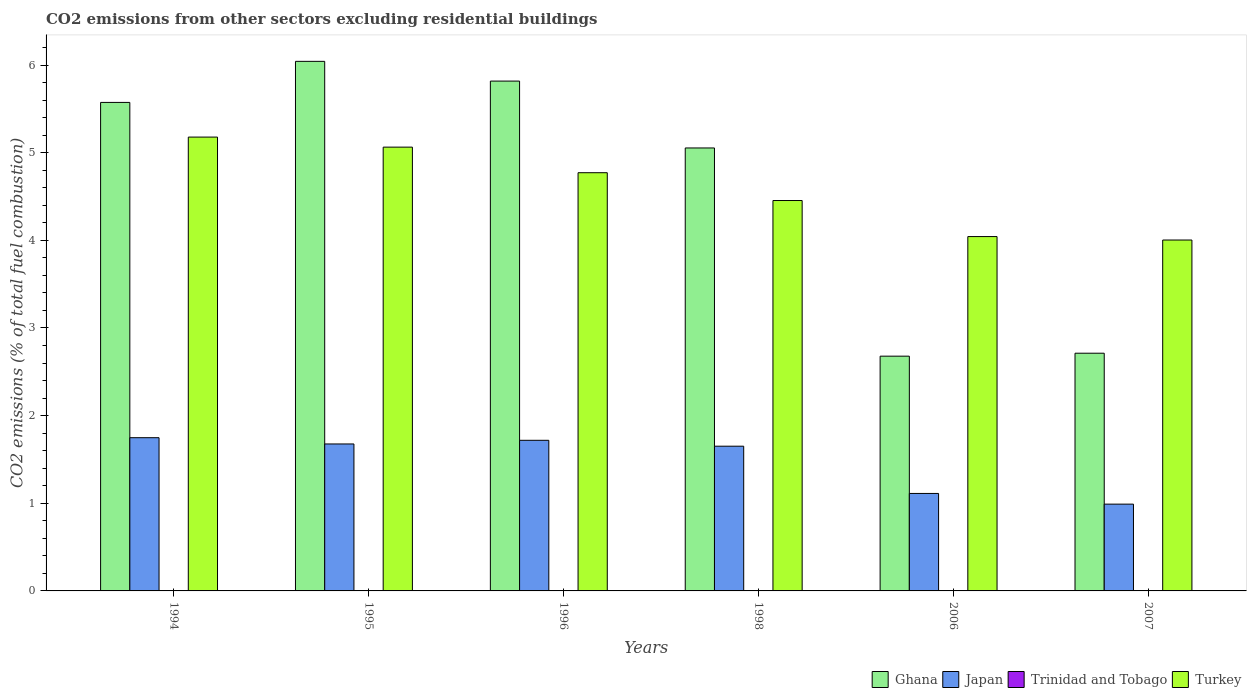How many different coloured bars are there?
Ensure brevity in your answer.  4. Are the number of bars per tick equal to the number of legend labels?
Make the answer very short. No. Are the number of bars on each tick of the X-axis equal?
Your answer should be compact. No. What is the label of the 6th group of bars from the left?
Give a very brief answer. 2007. What is the total CO2 emitted in Trinidad and Tobago in 1995?
Give a very brief answer. 0. Across all years, what is the maximum total CO2 emitted in Trinidad and Tobago?
Your answer should be very brief. 5.05750284541343e-17. Across all years, what is the minimum total CO2 emitted in Trinidad and Tobago?
Make the answer very short. 0. In which year was the total CO2 emitted in Trinidad and Tobago maximum?
Offer a very short reply. 2006. What is the total total CO2 emitted in Japan in the graph?
Offer a terse response. 8.9. What is the difference between the total CO2 emitted in Ghana in 1995 and that in 2006?
Make the answer very short. 3.36. What is the difference between the total CO2 emitted in Japan in 1998 and the total CO2 emitted in Turkey in 2006?
Make the answer very short. -2.39. What is the average total CO2 emitted in Trinidad and Tobago per year?
Ensure brevity in your answer.  1.6352453933809117e-17. In the year 1998, what is the difference between the total CO2 emitted in Turkey and total CO2 emitted in Ghana?
Offer a very short reply. -0.6. What is the ratio of the total CO2 emitted in Turkey in 1994 to that in 1998?
Provide a succinct answer. 1.16. Is the total CO2 emitted in Turkey in 1996 less than that in 2007?
Your answer should be compact. No. Is the difference between the total CO2 emitted in Turkey in 1995 and 1996 greater than the difference between the total CO2 emitted in Ghana in 1995 and 1996?
Provide a short and direct response. Yes. What is the difference between the highest and the second highest total CO2 emitted in Ghana?
Your answer should be very brief. 0.23. What is the difference between the highest and the lowest total CO2 emitted in Japan?
Offer a terse response. 0.76. In how many years, is the total CO2 emitted in Turkey greater than the average total CO2 emitted in Turkey taken over all years?
Give a very brief answer. 3. Is the sum of the total CO2 emitted in Japan in 1996 and 2007 greater than the maximum total CO2 emitted in Ghana across all years?
Give a very brief answer. No. Is it the case that in every year, the sum of the total CO2 emitted in Trinidad and Tobago and total CO2 emitted in Turkey is greater than the sum of total CO2 emitted in Ghana and total CO2 emitted in Japan?
Your answer should be very brief. No. How many bars are there?
Give a very brief answer. 20. How many years are there in the graph?
Provide a short and direct response. 6. What is the difference between two consecutive major ticks on the Y-axis?
Keep it short and to the point. 1. Are the values on the major ticks of Y-axis written in scientific E-notation?
Keep it short and to the point. No. Does the graph contain any zero values?
Your response must be concise. Yes. Does the graph contain grids?
Your answer should be compact. No. Where does the legend appear in the graph?
Offer a terse response. Bottom right. What is the title of the graph?
Ensure brevity in your answer.  CO2 emissions from other sectors excluding residential buildings. What is the label or title of the X-axis?
Provide a succinct answer. Years. What is the label or title of the Y-axis?
Your answer should be compact. CO2 emissions (% of total fuel combustion). What is the CO2 emissions (% of total fuel combustion) in Ghana in 1994?
Your answer should be very brief. 5.57. What is the CO2 emissions (% of total fuel combustion) of Japan in 1994?
Make the answer very short. 1.75. What is the CO2 emissions (% of total fuel combustion) in Turkey in 1994?
Give a very brief answer. 5.18. What is the CO2 emissions (% of total fuel combustion) of Ghana in 1995?
Your response must be concise. 6.04. What is the CO2 emissions (% of total fuel combustion) of Japan in 1995?
Your answer should be very brief. 1.68. What is the CO2 emissions (% of total fuel combustion) of Turkey in 1995?
Offer a terse response. 5.06. What is the CO2 emissions (% of total fuel combustion) of Ghana in 1996?
Make the answer very short. 5.82. What is the CO2 emissions (% of total fuel combustion) of Japan in 1996?
Offer a very short reply. 1.72. What is the CO2 emissions (% of total fuel combustion) in Turkey in 1996?
Give a very brief answer. 4.77. What is the CO2 emissions (% of total fuel combustion) in Ghana in 1998?
Offer a terse response. 5.05. What is the CO2 emissions (% of total fuel combustion) in Japan in 1998?
Offer a very short reply. 1.65. What is the CO2 emissions (% of total fuel combustion) in Turkey in 1998?
Offer a very short reply. 4.45. What is the CO2 emissions (% of total fuel combustion) in Ghana in 2006?
Your response must be concise. 2.68. What is the CO2 emissions (% of total fuel combustion) in Japan in 2006?
Provide a succinct answer. 1.11. What is the CO2 emissions (% of total fuel combustion) in Trinidad and Tobago in 2006?
Your answer should be compact. 5.05750284541343e-17. What is the CO2 emissions (% of total fuel combustion) in Turkey in 2006?
Your answer should be compact. 4.04. What is the CO2 emissions (% of total fuel combustion) of Ghana in 2007?
Offer a very short reply. 2.71. What is the CO2 emissions (% of total fuel combustion) in Japan in 2007?
Offer a terse response. 0.99. What is the CO2 emissions (% of total fuel combustion) of Trinidad and Tobago in 2007?
Provide a short and direct response. 4.75396951487204e-17. What is the CO2 emissions (% of total fuel combustion) in Turkey in 2007?
Keep it short and to the point. 4. Across all years, what is the maximum CO2 emissions (% of total fuel combustion) of Ghana?
Give a very brief answer. 6.04. Across all years, what is the maximum CO2 emissions (% of total fuel combustion) in Japan?
Keep it short and to the point. 1.75. Across all years, what is the maximum CO2 emissions (% of total fuel combustion) in Trinidad and Tobago?
Your answer should be compact. 5.05750284541343e-17. Across all years, what is the maximum CO2 emissions (% of total fuel combustion) of Turkey?
Provide a succinct answer. 5.18. Across all years, what is the minimum CO2 emissions (% of total fuel combustion) of Ghana?
Provide a short and direct response. 2.68. Across all years, what is the minimum CO2 emissions (% of total fuel combustion) in Japan?
Provide a succinct answer. 0.99. Across all years, what is the minimum CO2 emissions (% of total fuel combustion) in Turkey?
Offer a terse response. 4. What is the total CO2 emissions (% of total fuel combustion) in Ghana in the graph?
Your response must be concise. 27.88. What is the total CO2 emissions (% of total fuel combustion) in Japan in the graph?
Provide a succinct answer. 8.9. What is the total CO2 emissions (% of total fuel combustion) in Turkey in the graph?
Provide a succinct answer. 27.51. What is the difference between the CO2 emissions (% of total fuel combustion) in Ghana in 1994 and that in 1995?
Your answer should be compact. -0.47. What is the difference between the CO2 emissions (% of total fuel combustion) of Japan in 1994 and that in 1995?
Your response must be concise. 0.07. What is the difference between the CO2 emissions (% of total fuel combustion) of Turkey in 1994 and that in 1995?
Provide a short and direct response. 0.11. What is the difference between the CO2 emissions (% of total fuel combustion) in Ghana in 1994 and that in 1996?
Your answer should be compact. -0.24. What is the difference between the CO2 emissions (% of total fuel combustion) of Japan in 1994 and that in 1996?
Make the answer very short. 0.03. What is the difference between the CO2 emissions (% of total fuel combustion) of Turkey in 1994 and that in 1996?
Provide a succinct answer. 0.41. What is the difference between the CO2 emissions (% of total fuel combustion) of Ghana in 1994 and that in 1998?
Keep it short and to the point. 0.52. What is the difference between the CO2 emissions (% of total fuel combustion) in Japan in 1994 and that in 1998?
Provide a short and direct response. 0.1. What is the difference between the CO2 emissions (% of total fuel combustion) in Turkey in 1994 and that in 1998?
Offer a terse response. 0.72. What is the difference between the CO2 emissions (% of total fuel combustion) of Ghana in 1994 and that in 2006?
Your response must be concise. 2.9. What is the difference between the CO2 emissions (% of total fuel combustion) in Japan in 1994 and that in 2006?
Provide a succinct answer. 0.64. What is the difference between the CO2 emissions (% of total fuel combustion) of Turkey in 1994 and that in 2006?
Offer a very short reply. 1.14. What is the difference between the CO2 emissions (% of total fuel combustion) of Ghana in 1994 and that in 2007?
Provide a short and direct response. 2.86. What is the difference between the CO2 emissions (% of total fuel combustion) in Japan in 1994 and that in 2007?
Make the answer very short. 0.76. What is the difference between the CO2 emissions (% of total fuel combustion) in Turkey in 1994 and that in 2007?
Ensure brevity in your answer.  1.17. What is the difference between the CO2 emissions (% of total fuel combustion) in Ghana in 1995 and that in 1996?
Ensure brevity in your answer.  0.23. What is the difference between the CO2 emissions (% of total fuel combustion) in Japan in 1995 and that in 1996?
Offer a terse response. -0.04. What is the difference between the CO2 emissions (% of total fuel combustion) in Turkey in 1995 and that in 1996?
Give a very brief answer. 0.29. What is the difference between the CO2 emissions (% of total fuel combustion) in Ghana in 1995 and that in 1998?
Your answer should be very brief. 0.99. What is the difference between the CO2 emissions (% of total fuel combustion) in Japan in 1995 and that in 1998?
Provide a short and direct response. 0.03. What is the difference between the CO2 emissions (% of total fuel combustion) in Turkey in 1995 and that in 1998?
Offer a very short reply. 0.61. What is the difference between the CO2 emissions (% of total fuel combustion) in Ghana in 1995 and that in 2006?
Keep it short and to the point. 3.36. What is the difference between the CO2 emissions (% of total fuel combustion) in Japan in 1995 and that in 2006?
Your answer should be very brief. 0.56. What is the difference between the CO2 emissions (% of total fuel combustion) of Turkey in 1995 and that in 2006?
Offer a very short reply. 1.02. What is the difference between the CO2 emissions (% of total fuel combustion) of Ghana in 1995 and that in 2007?
Your answer should be very brief. 3.33. What is the difference between the CO2 emissions (% of total fuel combustion) in Japan in 1995 and that in 2007?
Your answer should be very brief. 0.69. What is the difference between the CO2 emissions (% of total fuel combustion) in Turkey in 1995 and that in 2007?
Offer a very short reply. 1.06. What is the difference between the CO2 emissions (% of total fuel combustion) of Ghana in 1996 and that in 1998?
Make the answer very short. 0.76. What is the difference between the CO2 emissions (% of total fuel combustion) of Japan in 1996 and that in 1998?
Ensure brevity in your answer.  0.07. What is the difference between the CO2 emissions (% of total fuel combustion) in Turkey in 1996 and that in 1998?
Offer a terse response. 0.32. What is the difference between the CO2 emissions (% of total fuel combustion) of Ghana in 1996 and that in 2006?
Offer a very short reply. 3.14. What is the difference between the CO2 emissions (% of total fuel combustion) in Japan in 1996 and that in 2006?
Make the answer very short. 0.61. What is the difference between the CO2 emissions (% of total fuel combustion) in Turkey in 1996 and that in 2006?
Your response must be concise. 0.73. What is the difference between the CO2 emissions (% of total fuel combustion) in Ghana in 1996 and that in 2007?
Give a very brief answer. 3.1. What is the difference between the CO2 emissions (% of total fuel combustion) of Japan in 1996 and that in 2007?
Give a very brief answer. 0.73. What is the difference between the CO2 emissions (% of total fuel combustion) of Turkey in 1996 and that in 2007?
Provide a succinct answer. 0.77. What is the difference between the CO2 emissions (% of total fuel combustion) in Ghana in 1998 and that in 2006?
Offer a terse response. 2.38. What is the difference between the CO2 emissions (% of total fuel combustion) in Japan in 1998 and that in 2006?
Offer a very short reply. 0.54. What is the difference between the CO2 emissions (% of total fuel combustion) in Turkey in 1998 and that in 2006?
Keep it short and to the point. 0.41. What is the difference between the CO2 emissions (% of total fuel combustion) of Ghana in 1998 and that in 2007?
Give a very brief answer. 2.34. What is the difference between the CO2 emissions (% of total fuel combustion) of Japan in 1998 and that in 2007?
Provide a short and direct response. 0.66. What is the difference between the CO2 emissions (% of total fuel combustion) in Turkey in 1998 and that in 2007?
Keep it short and to the point. 0.45. What is the difference between the CO2 emissions (% of total fuel combustion) of Ghana in 2006 and that in 2007?
Offer a terse response. -0.03. What is the difference between the CO2 emissions (% of total fuel combustion) of Japan in 2006 and that in 2007?
Your answer should be compact. 0.12. What is the difference between the CO2 emissions (% of total fuel combustion) in Trinidad and Tobago in 2006 and that in 2007?
Your response must be concise. 0. What is the difference between the CO2 emissions (% of total fuel combustion) of Turkey in 2006 and that in 2007?
Keep it short and to the point. 0.04. What is the difference between the CO2 emissions (% of total fuel combustion) of Ghana in 1994 and the CO2 emissions (% of total fuel combustion) of Japan in 1995?
Make the answer very short. 3.9. What is the difference between the CO2 emissions (% of total fuel combustion) of Ghana in 1994 and the CO2 emissions (% of total fuel combustion) of Turkey in 1995?
Provide a short and direct response. 0.51. What is the difference between the CO2 emissions (% of total fuel combustion) in Japan in 1994 and the CO2 emissions (% of total fuel combustion) in Turkey in 1995?
Provide a short and direct response. -3.32. What is the difference between the CO2 emissions (% of total fuel combustion) of Ghana in 1994 and the CO2 emissions (% of total fuel combustion) of Japan in 1996?
Your answer should be compact. 3.86. What is the difference between the CO2 emissions (% of total fuel combustion) of Ghana in 1994 and the CO2 emissions (% of total fuel combustion) of Turkey in 1996?
Give a very brief answer. 0.8. What is the difference between the CO2 emissions (% of total fuel combustion) of Japan in 1994 and the CO2 emissions (% of total fuel combustion) of Turkey in 1996?
Give a very brief answer. -3.02. What is the difference between the CO2 emissions (% of total fuel combustion) of Ghana in 1994 and the CO2 emissions (% of total fuel combustion) of Japan in 1998?
Provide a succinct answer. 3.92. What is the difference between the CO2 emissions (% of total fuel combustion) in Ghana in 1994 and the CO2 emissions (% of total fuel combustion) in Turkey in 1998?
Ensure brevity in your answer.  1.12. What is the difference between the CO2 emissions (% of total fuel combustion) of Japan in 1994 and the CO2 emissions (% of total fuel combustion) of Turkey in 1998?
Provide a short and direct response. -2.71. What is the difference between the CO2 emissions (% of total fuel combustion) in Ghana in 1994 and the CO2 emissions (% of total fuel combustion) in Japan in 2006?
Provide a short and direct response. 4.46. What is the difference between the CO2 emissions (% of total fuel combustion) of Ghana in 1994 and the CO2 emissions (% of total fuel combustion) of Trinidad and Tobago in 2006?
Your answer should be compact. 5.57. What is the difference between the CO2 emissions (% of total fuel combustion) in Ghana in 1994 and the CO2 emissions (% of total fuel combustion) in Turkey in 2006?
Give a very brief answer. 1.53. What is the difference between the CO2 emissions (% of total fuel combustion) of Japan in 1994 and the CO2 emissions (% of total fuel combustion) of Trinidad and Tobago in 2006?
Offer a terse response. 1.75. What is the difference between the CO2 emissions (% of total fuel combustion) in Japan in 1994 and the CO2 emissions (% of total fuel combustion) in Turkey in 2006?
Offer a very short reply. -2.29. What is the difference between the CO2 emissions (% of total fuel combustion) of Ghana in 1994 and the CO2 emissions (% of total fuel combustion) of Japan in 2007?
Offer a terse response. 4.58. What is the difference between the CO2 emissions (% of total fuel combustion) in Ghana in 1994 and the CO2 emissions (% of total fuel combustion) in Trinidad and Tobago in 2007?
Provide a short and direct response. 5.57. What is the difference between the CO2 emissions (% of total fuel combustion) of Ghana in 1994 and the CO2 emissions (% of total fuel combustion) of Turkey in 2007?
Give a very brief answer. 1.57. What is the difference between the CO2 emissions (% of total fuel combustion) in Japan in 1994 and the CO2 emissions (% of total fuel combustion) in Trinidad and Tobago in 2007?
Offer a very short reply. 1.75. What is the difference between the CO2 emissions (% of total fuel combustion) in Japan in 1994 and the CO2 emissions (% of total fuel combustion) in Turkey in 2007?
Provide a short and direct response. -2.26. What is the difference between the CO2 emissions (% of total fuel combustion) in Ghana in 1995 and the CO2 emissions (% of total fuel combustion) in Japan in 1996?
Give a very brief answer. 4.32. What is the difference between the CO2 emissions (% of total fuel combustion) of Ghana in 1995 and the CO2 emissions (% of total fuel combustion) of Turkey in 1996?
Your answer should be very brief. 1.27. What is the difference between the CO2 emissions (% of total fuel combustion) of Japan in 1995 and the CO2 emissions (% of total fuel combustion) of Turkey in 1996?
Your answer should be very brief. -3.09. What is the difference between the CO2 emissions (% of total fuel combustion) of Ghana in 1995 and the CO2 emissions (% of total fuel combustion) of Japan in 1998?
Provide a succinct answer. 4.39. What is the difference between the CO2 emissions (% of total fuel combustion) in Ghana in 1995 and the CO2 emissions (% of total fuel combustion) in Turkey in 1998?
Ensure brevity in your answer.  1.59. What is the difference between the CO2 emissions (% of total fuel combustion) of Japan in 1995 and the CO2 emissions (% of total fuel combustion) of Turkey in 1998?
Provide a short and direct response. -2.78. What is the difference between the CO2 emissions (% of total fuel combustion) in Ghana in 1995 and the CO2 emissions (% of total fuel combustion) in Japan in 2006?
Give a very brief answer. 4.93. What is the difference between the CO2 emissions (% of total fuel combustion) of Ghana in 1995 and the CO2 emissions (% of total fuel combustion) of Trinidad and Tobago in 2006?
Provide a short and direct response. 6.04. What is the difference between the CO2 emissions (% of total fuel combustion) of Ghana in 1995 and the CO2 emissions (% of total fuel combustion) of Turkey in 2006?
Provide a succinct answer. 2. What is the difference between the CO2 emissions (% of total fuel combustion) in Japan in 1995 and the CO2 emissions (% of total fuel combustion) in Trinidad and Tobago in 2006?
Your answer should be compact. 1.68. What is the difference between the CO2 emissions (% of total fuel combustion) of Japan in 1995 and the CO2 emissions (% of total fuel combustion) of Turkey in 2006?
Offer a terse response. -2.37. What is the difference between the CO2 emissions (% of total fuel combustion) in Ghana in 1995 and the CO2 emissions (% of total fuel combustion) in Japan in 2007?
Give a very brief answer. 5.05. What is the difference between the CO2 emissions (% of total fuel combustion) in Ghana in 1995 and the CO2 emissions (% of total fuel combustion) in Trinidad and Tobago in 2007?
Make the answer very short. 6.04. What is the difference between the CO2 emissions (% of total fuel combustion) in Ghana in 1995 and the CO2 emissions (% of total fuel combustion) in Turkey in 2007?
Offer a very short reply. 2.04. What is the difference between the CO2 emissions (% of total fuel combustion) of Japan in 1995 and the CO2 emissions (% of total fuel combustion) of Trinidad and Tobago in 2007?
Provide a short and direct response. 1.68. What is the difference between the CO2 emissions (% of total fuel combustion) in Japan in 1995 and the CO2 emissions (% of total fuel combustion) in Turkey in 2007?
Your answer should be very brief. -2.33. What is the difference between the CO2 emissions (% of total fuel combustion) of Ghana in 1996 and the CO2 emissions (% of total fuel combustion) of Japan in 1998?
Offer a very short reply. 4.17. What is the difference between the CO2 emissions (% of total fuel combustion) of Ghana in 1996 and the CO2 emissions (% of total fuel combustion) of Turkey in 1998?
Offer a very short reply. 1.36. What is the difference between the CO2 emissions (% of total fuel combustion) of Japan in 1996 and the CO2 emissions (% of total fuel combustion) of Turkey in 1998?
Keep it short and to the point. -2.74. What is the difference between the CO2 emissions (% of total fuel combustion) of Ghana in 1996 and the CO2 emissions (% of total fuel combustion) of Japan in 2006?
Your response must be concise. 4.7. What is the difference between the CO2 emissions (% of total fuel combustion) of Ghana in 1996 and the CO2 emissions (% of total fuel combustion) of Trinidad and Tobago in 2006?
Give a very brief answer. 5.82. What is the difference between the CO2 emissions (% of total fuel combustion) of Ghana in 1996 and the CO2 emissions (% of total fuel combustion) of Turkey in 2006?
Your response must be concise. 1.77. What is the difference between the CO2 emissions (% of total fuel combustion) in Japan in 1996 and the CO2 emissions (% of total fuel combustion) in Trinidad and Tobago in 2006?
Keep it short and to the point. 1.72. What is the difference between the CO2 emissions (% of total fuel combustion) of Japan in 1996 and the CO2 emissions (% of total fuel combustion) of Turkey in 2006?
Give a very brief answer. -2.32. What is the difference between the CO2 emissions (% of total fuel combustion) in Ghana in 1996 and the CO2 emissions (% of total fuel combustion) in Japan in 2007?
Your response must be concise. 4.83. What is the difference between the CO2 emissions (% of total fuel combustion) in Ghana in 1996 and the CO2 emissions (% of total fuel combustion) in Trinidad and Tobago in 2007?
Provide a short and direct response. 5.82. What is the difference between the CO2 emissions (% of total fuel combustion) in Ghana in 1996 and the CO2 emissions (% of total fuel combustion) in Turkey in 2007?
Your response must be concise. 1.81. What is the difference between the CO2 emissions (% of total fuel combustion) in Japan in 1996 and the CO2 emissions (% of total fuel combustion) in Trinidad and Tobago in 2007?
Keep it short and to the point. 1.72. What is the difference between the CO2 emissions (% of total fuel combustion) of Japan in 1996 and the CO2 emissions (% of total fuel combustion) of Turkey in 2007?
Keep it short and to the point. -2.29. What is the difference between the CO2 emissions (% of total fuel combustion) of Ghana in 1998 and the CO2 emissions (% of total fuel combustion) of Japan in 2006?
Make the answer very short. 3.94. What is the difference between the CO2 emissions (% of total fuel combustion) of Ghana in 1998 and the CO2 emissions (% of total fuel combustion) of Trinidad and Tobago in 2006?
Your response must be concise. 5.05. What is the difference between the CO2 emissions (% of total fuel combustion) in Ghana in 1998 and the CO2 emissions (% of total fuel combustion) in Turkey in 2006?
Offer a terse response. 1.01. What is the difference between the CO2 emissions (% of total fuel combustion) of Japan in 1998 and the CO2 emissions (% of total fuel combustion) of Trinidad and Tobago in 2006?
Provide a succinct answer. 1.65. What is the difference between the CO2 emissions (% of total fuel combustion) of Japan in 1998 and the CO2 emissions (% of total fuel combustion) of Turkey in 2006?
Make the answer very short. -2.39. What is the difference between the CO2 emissions (% of total fuel combustion) in Ghana in 1998 and the CO2 emissions (% of total fuel combustion) in Japan in 2007?
Provide a short and direct response. 4.06. What is the difference between the CO2 emissions (% of total fuel combustion) in Ghana in 1998 and the CO2 emissions (% of total fuel combustion) in Trinidad and Tobago in 2007?
Give a very brief answer. 5.05. What is the difference between the CO2 emissions (% of total fuel combustion) in Ghana in 1998 and the CO2 emissions (% of total fuel combustion) in Turkey in 2007?
Your answer should be compact. 1.05. What is the difference between the CO2 emissions (% of total fuel combustion) of Japan in 1998 and the CO2 emissions (% of total fuel combustion) of Trinidad and Tobago in 2007?
Make the answer very short. 1.65. What is the difference between the CO2 emissions (% of total fuel combustion) of Japan in 1998 and the CO2 emissions (% of total fuel combustion) of Turkey in 2007?
Your answer should be very brief. -2.35. What is the difference between the CO2 emissions (% of total fuel combustion) in Ghana in 2006 and the CO2 emissions (% of total fuel combustion) in Japan in 2007?
Your answer should be compact. 1.69. What is the difference between the CO2 emissions (% of total fuel combustion) of Ghana in 2006 and the CO2 emissions (% of total fuel combustion) of Trinidad and Tobago in 2007?
Make the answer very short. 2.68. What is the difference between the CO2 emissions (% of total fuel combustion) of Ghana in 2006 and the CO2 emissions (% of total fuel combustion) of Turkey in 2007?
Your answer should be very brief. -1.33. What is the difference between the CO2 emissions (% of total fuel combustion) of Japan in 2006 and the CO2 emissions (% of total fuel combustion) of Trinidad and Tobago in 2007?
Your response must be concise. 1.11. What is the difference between the CO2 emissions (% of total fuel combustion) of Japan in 2006 and the CO2 emissions (% of total fuel combustion) of Turkey in 2007?
Your answer should be very brief. -2.89. What is the difference between the CO2 emissions (% of total fuel combustion) in Trinidad and Tobago in 2006 and the CO2 emissions (% of total fuel combustion) in Turkey in 2007?
Provide a short and direct response. -4. What is the average CO2 emissions (% of total fuel combustion) of Ghana per year?
Offer a very short reply. 4.65. What is the average CO2 emissions (% of total fuel combustion) in Japan per year?
Make the answer very short. 1.48. What is the average CO2 emissions (% of total fuel combustion) in Trinidad and Tobago per year?
Your answer should be very brief. 0. What is the average CO2 emissions (% of total fuel combustion) in Turkey per year?
Offer a very short reply. 4.59. In the year 1994, what is the difference between the CO2 emissions (% of total fuel combustion) of Ghana and CO2 emissions (% of total fuel combustion) of Japan?
Offer a very short reply. 3.83. In the year 1994, what is the difference between the CO2 emissions (% of total fuel combustion) in Ghana and CO2 emissions (% of total fuel combustion) in Turkey?
Provide a succinct answer. 0.4. In the year 1994, what is the difference between the CO2 emissions (% of total fuel combustion) in Japan and CO2 emissions (% of total fuel combustion) in Turkey?
Give a very brief answer. -3.43. In the year 1995, what is the difference between the CO2 emissions (% of total fuel combustion) in Ghana and CO2 emissions (% of total fuel combustion) in Japan?
Offer a very short reply. 4.37. In the year 1995, what is the difference between the CO2 emissions (% of total fuel combustion) in Ghana and CO2 emissions (% of total fuel combustion) in Turkey?
Make the answer very short. 0.98. In the year 1995, what is the difference between the CO2 emissions (% of total fuel combustion) in Japan and CO2 emissions (% of total fuel combustion) in Turkey?
Ensure brevity in your answer.  -3.39. In the year 1996, what is the difference between the CO2 emissions (% of total fuel combustion) in Ghana and CO2 emissions (% of total fuel combustion) in Japan?
Offer a very short reply. 4.1. In the year 1996, what is the difference between the CO2 emissions (% of total fuel combustion) of Ghana and CO2 emissions (% of total fuel combustion) of Turkey?
Offer a very short reply. 1.05. In the year 1996, what is the difference between the CO2 emissions (% of total fuel combustion) of Japan and CO2 emissions (% of total fuel combustion) of Turkey?
Provide a short and direct response. -3.05. In the year 1998, what is the difference between the CO2 emissions (% of total fuel combustion) of Ghana and CO2 emissions (% of total fuel combustion) of Japan?
Offer a very short reply. 3.4. In the year 1998, what is the difference between the CO2 emissions (% of total fuel combustion) of Ghana and CO2 emissions (% of total fuel combustion) of Turkey?
Your response must be concise. 0.6. In the year 1998, what is the difference between the CO2 emissions (% of total fuel combustion) of Japan and CO2 emissions (% of total fuel combustion) of Turkey?
Make the answer very short. -2.8. In the year 2006, what is the difference between the CO2 emissions (% of total fuel combustion) in Ghana and CO2 emissions (% of total fuel combustion) in Japan?
Give a very brief answer. 1.57. In the year 2006, what is the difference between the CO2 emissions (% of total fuel combustion) of Ghana and CO2 emissions (% of total fuel combustion) of Trinidad and Tobago?
Your answer should be compact. 2.68. In the year 2006, what is the difference between the CO2 emissions (% of total fuel combustion) in Ghana and CO2 emissions (% of total fuel combustion) in Turkey?
Your response must be concise. -1.36. In the year 2006, what is the difference between the CO2 emissions (% of total fuel combustion) of Japan and CO2 emissions (% of total fuel combustion) of Trinidad and Tobago?
Make the answer very short. 1.11. In the year 2006, what is the difference between the CO2 emissions (% of total fuel combustion) of Japan and CO2 emissions (% of total fuel combustion) of Turkey?
Make the answer very short. -2.93. In the year 2006, what is the difference between the CO2 emissions (% of total fuel combustion) in Trinidad and Tobago and CO2 emissions (% of total fuel combustion) in Turkey?
Keep it short and to the point. -4.04. In the year 2007, what is the difference between the CO2 emissions (% of total fuel combustion) of Ghana and CO2 emissions (% of total fuel combustion) of Japan?
Give a very brief answer. 1.72. In the year 2007, what is the difference between the CO2 emissions (% of total fuel combustion) of Ghana and CO2 emissions (% of total fuel combustion) of Trinidad and Tobago?
Provide a short and direct response. 2.71. In the year 2007, what is the difference between the CO2 emissions (% of total fuel combustion) of Ghana and CO2 emissions (% of total fuel combustion) of Turkey?
Give a very brief answer. -1.29. In the year 2007, what is the difference between the CO2 emissions (% of total fuel combustion) of Japan and CO2 emissions (% of total fuel combustion) of Trinidad and Tobago?
Give a very brief answer. 0.99. In the year 2007, what is the difference between the CO2 emissions (% of total fuel combustion) in Japan and CO2 emissions (% of total fuel combustion) in Turkey?
Ensure brevity in your answer.  -3.01. In the year 2007, what is the difference between the CO2 emissions (% of total fuel combustion) in Trinidad and Tobago and CO2 emissions (% of total fuel combustion) in Turkey?
Keep it short and to the point. -4. What is the ratio of the CO2 emissions (% of total fuel combustion) of Ghana in 1994 to that in 1995?
Provide a short and direct response. 0.92. What is the ratio of the CO2 emissions (% of total fuel combustion) in Japan in 1994 to that in 1995?
Your answer should be compact. 1.04. What is the ratio of the CO2 emissions (% of total fuel combustion) of Turkey in 1994 to that in 1995?
Your answer should be compact. 1.02. What is the ratio of the CO2 emissions (% of total fuel combustion) in Ghana in 1994 to that in 1996?
Offer a terse response. 0.96. What is the ratio of the CO2 emissions (% of total fuel combustion) of Japan in 1994 to that in 1996?
Make the answer very short. 1.02. What is the ratio of the CO2 emissions (% of total fuel combustion) in Turkey in 1994 to that in 1996?
Ensure brevity in your answer.  1.09. What is the ratio of the CO2 emissions (% of total fuel combustion) of Ghana in 1994 to that in 1998?
Offer a very short reply. 1.1. What is the ratio of the CO2 emissions (% of total fuel combustion) in Japan in 1994 to that in 1998?
Your answer should be very brief. 1.06. What is the ratio of the CO2 emissions (% of total fuel combustion) of Turkey in 1994 to that in 1998?
Make the answer very short. 1.16. What is the ratio of the CO2 emissions (% of total fuel combustion) of Ghana in 1994 to that in 2006?
Your answer should be very brief. 2.08. What is the ratio of the CO2 emissions (% of total fuel combustion) in Japan in 1994 to that in 2006?
Provide a short and direct response. 1.57. What is the ratio of the CO2 emissions (% of total fuel combustion) in Turkey in 1994 to that in 2006?
Provide a short and direct response. 1.28. What is the ratio of the CO2 emissions (% of total fuel combustion) in Ghana in 1994 to that in 2007?
Offer a terse response. 2.06. What is the ratio of the CO2 emissions (% of total fuel combustion) of Japan in 1994 to that in 2007?
Make the answer very short. 1.77. What is the ratio of the CO2 emissions (% of total fuel combustion) of Turkey in 1994 to that in 2007?
Give a very brief answer. 1.29. What is the ratio of the CO2 emissions (% of total fuel combustion) in Ghana in 1995 to that in 1996?
Your response must be concise. 1.04. What is the ratio of the CO2 emissions (% of total fuel combustion) in Japan in 1995 to that in 1996?
Your response must be concise. 0.98. What is the ratio of the CO2 emissions (% of total fuel combustion) of Turkey in 1995 to that in 1996?
Make the answer very short. 1.06. What is the ratio of the CO2 emissions (% of total fuel combustion) in Ghana in 1995 to that in 1998?
Provide a short and direct response. 1.2. What is the ratio of the CO2 emissions (% of total fuel combustion) of Japan in 1995 to that in 1998?
Make the answer very short. 1.02. What is the ratio of the CO2 emissions (% of total fuel combustion) of Turkey in 1995 to that in 1998?
Give a very brief answer. 1.14. What is the ratio of the CO2 emissions (% of total fuel combustion) of Ghana in 1995 to that in 2006?
Your response must be concise. 2.26. What is the ratio of the CO2 emissions (% of total fuel combustion) in Japan in 1995 to that in 2006?
Make the answer very short. 1.51. What is the ratio of the CO2 emissions (% of total fuel combustion) in Turkey in 1995 to that in 2006?
Your response must be concise. 1.25. What is the ratio of the CO2 emissions (% of total fuel combustion) of Ghana in 1995 to that in 2007?
Provide a succinct answer. 2.23. What is the ratio of the CO2 emissions (% of total fuel combustion) in Japan in 1995 to that in 2007?
Make the answer very short. 1.69. What is the ratio of the CO2 emissions (% of total fuel combustion) in Turkey in 1995 to that in 2007?
Your response must be concise. 1.26. What is the ratio of the CO2 emissions (% of total fuel combustion) of Ghana in 1996 to that in 1998?
Offer a terse response. 1.15. What is the ratio of the CO2 emissions (% of total fuel combustion) of Japan in 1996 to that in 1998?
Make the answer very short. 1.04. What is the ratio of the CO2 emissions (% of total fuel combustion) of Turkey in 1996 to that in 1998?
Your answer should be compact. 1.07. What is the ratio of the CO2 emissions (% of total fuel combustion) in Ghana in 1996 to that in 2006?
Ensure brevity in your answer.  2.17. What is the ratio of the CO2 emissions (% of total fuel combustion) of Japan in 1996 to that in 2006?
Ensure brevity in your answer.  1.54. What is the ratio of the CO2 emissions (% of total fuel combustion) of Turkey in 1996 to that in 2006?
Keep it short and to the point. 1.18. What is the ratio of the CO2 emissions (% of total fuel combustion) in Ghana in 1996 to that in 2007?
Your response must be concise. 2.14. What is the ratio of the CO2 emissions (% of total fuel combustion) of Japan in 1996 to that in 2007?
Your answer should be compact. 1.74. What is the ratio of the CO2 emissions (% of total fuel combustion) in Turkey in 1996 to that in 2007?
Your response must be concise. 1.19. What is the ratio of the CO2 emissions (% of total fuel combustion) of Ghana in 1998 to that in 2006?
Your answer should be compact. 1.89. What is the ratio of the CO2 emissions (% of total fuel combustion) of Japan in 1998 to that in 2006?
Keep it short and to the point. 1.48. What is the ratio of the CO2 emissions (% of total fuel combustion) of Turkey in 1998 to that in 2006?
Make the answer very short. 1.1. What is the ratio of the CO2 emissions (% of total fuel combustion) in Ghana in 1998 to that in 2007?
Make the answer very short. 1.86. What is the ratio of the CO2 emissions (% of total fuel combustion) in Japan in 1998 to that in 2007?
Provide a short and direct response. 1.67. What is the ratio of the CO2 emissions (% of total fuel combustion) in Turkey in 1998 to that in 2007?
Your response must be concise. 1.11. What is the ratio of the CO2 emissions (% of total fuel combustion) in Ghana in 2006 to that in 2007?
Your response must be concise. 0.99. What is the ratio of the CO2 emissions (% of total fuel combustion) in Japan in 2006 to that in 2007?
Keep it short and to the point. 1.12. What is the ratio of the CO2 emissions (% of total fuel combustion) of Trinidad and Tobago in 2006 to that in 2007?
Give a very brief answer. 1.06. What is the ratio of the CO2 emissions (% of total fuel combustion) of Turkey in 2006 to that in 2007?
Ensure brevity in your answer.  1.01. What is the difference between the highest and the second highest CO2 emissions (% of total fuel combustion) of Ghana?
Offer a very short reply. 0.23. What is the difference between the highest and the second highest CO2 emissions (% of total fuel combustion) in Japan?
Provide a succinct answer. 0.03. What is the difference between the highest and the second highest CO2 emissions (% of total fuel combustion) of Turkey?
Make the answer very short. 0.11. What is the difference between the highest and the lowest CO2 emissions (% of total fuel combustion) of Ghana?
Provide a succinct answer. 3.36. What is the difference between the highest and the lowest CO2 emissions (% of total fuel combustion) of Japan?
Offer a terse response. 0.76. What is the difference between the highest and the lowest CO2 emissions (% of total fuel combustion) of Turkey?
Offer a terse response. 1.17. 